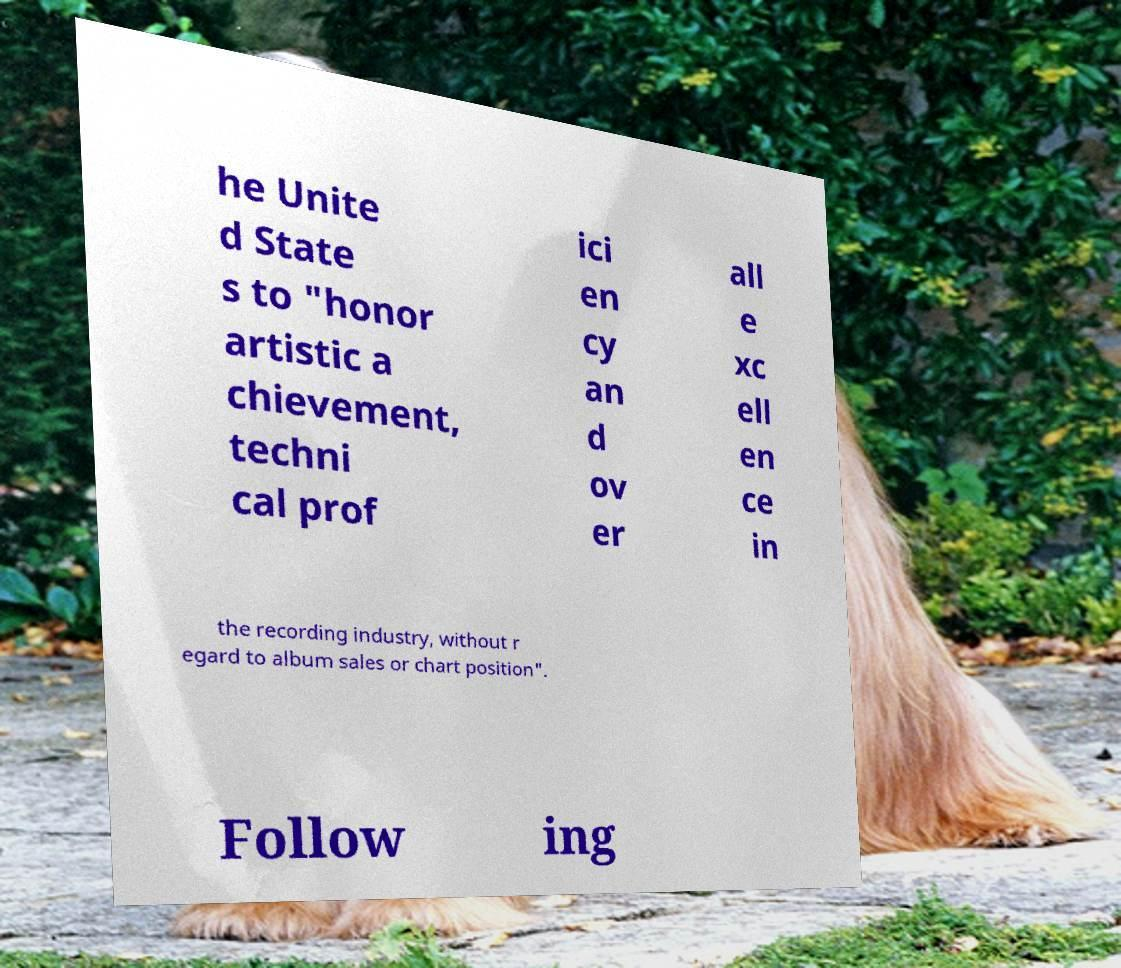Can you accurately transcribe the text from the provided image for me? he Unite d State s to "honor artistic a chievement, techni cal prof ici en cy an d ov er all e xc ell en ce in the recording industry, without r egard to album sales or chart position". Follow ing 